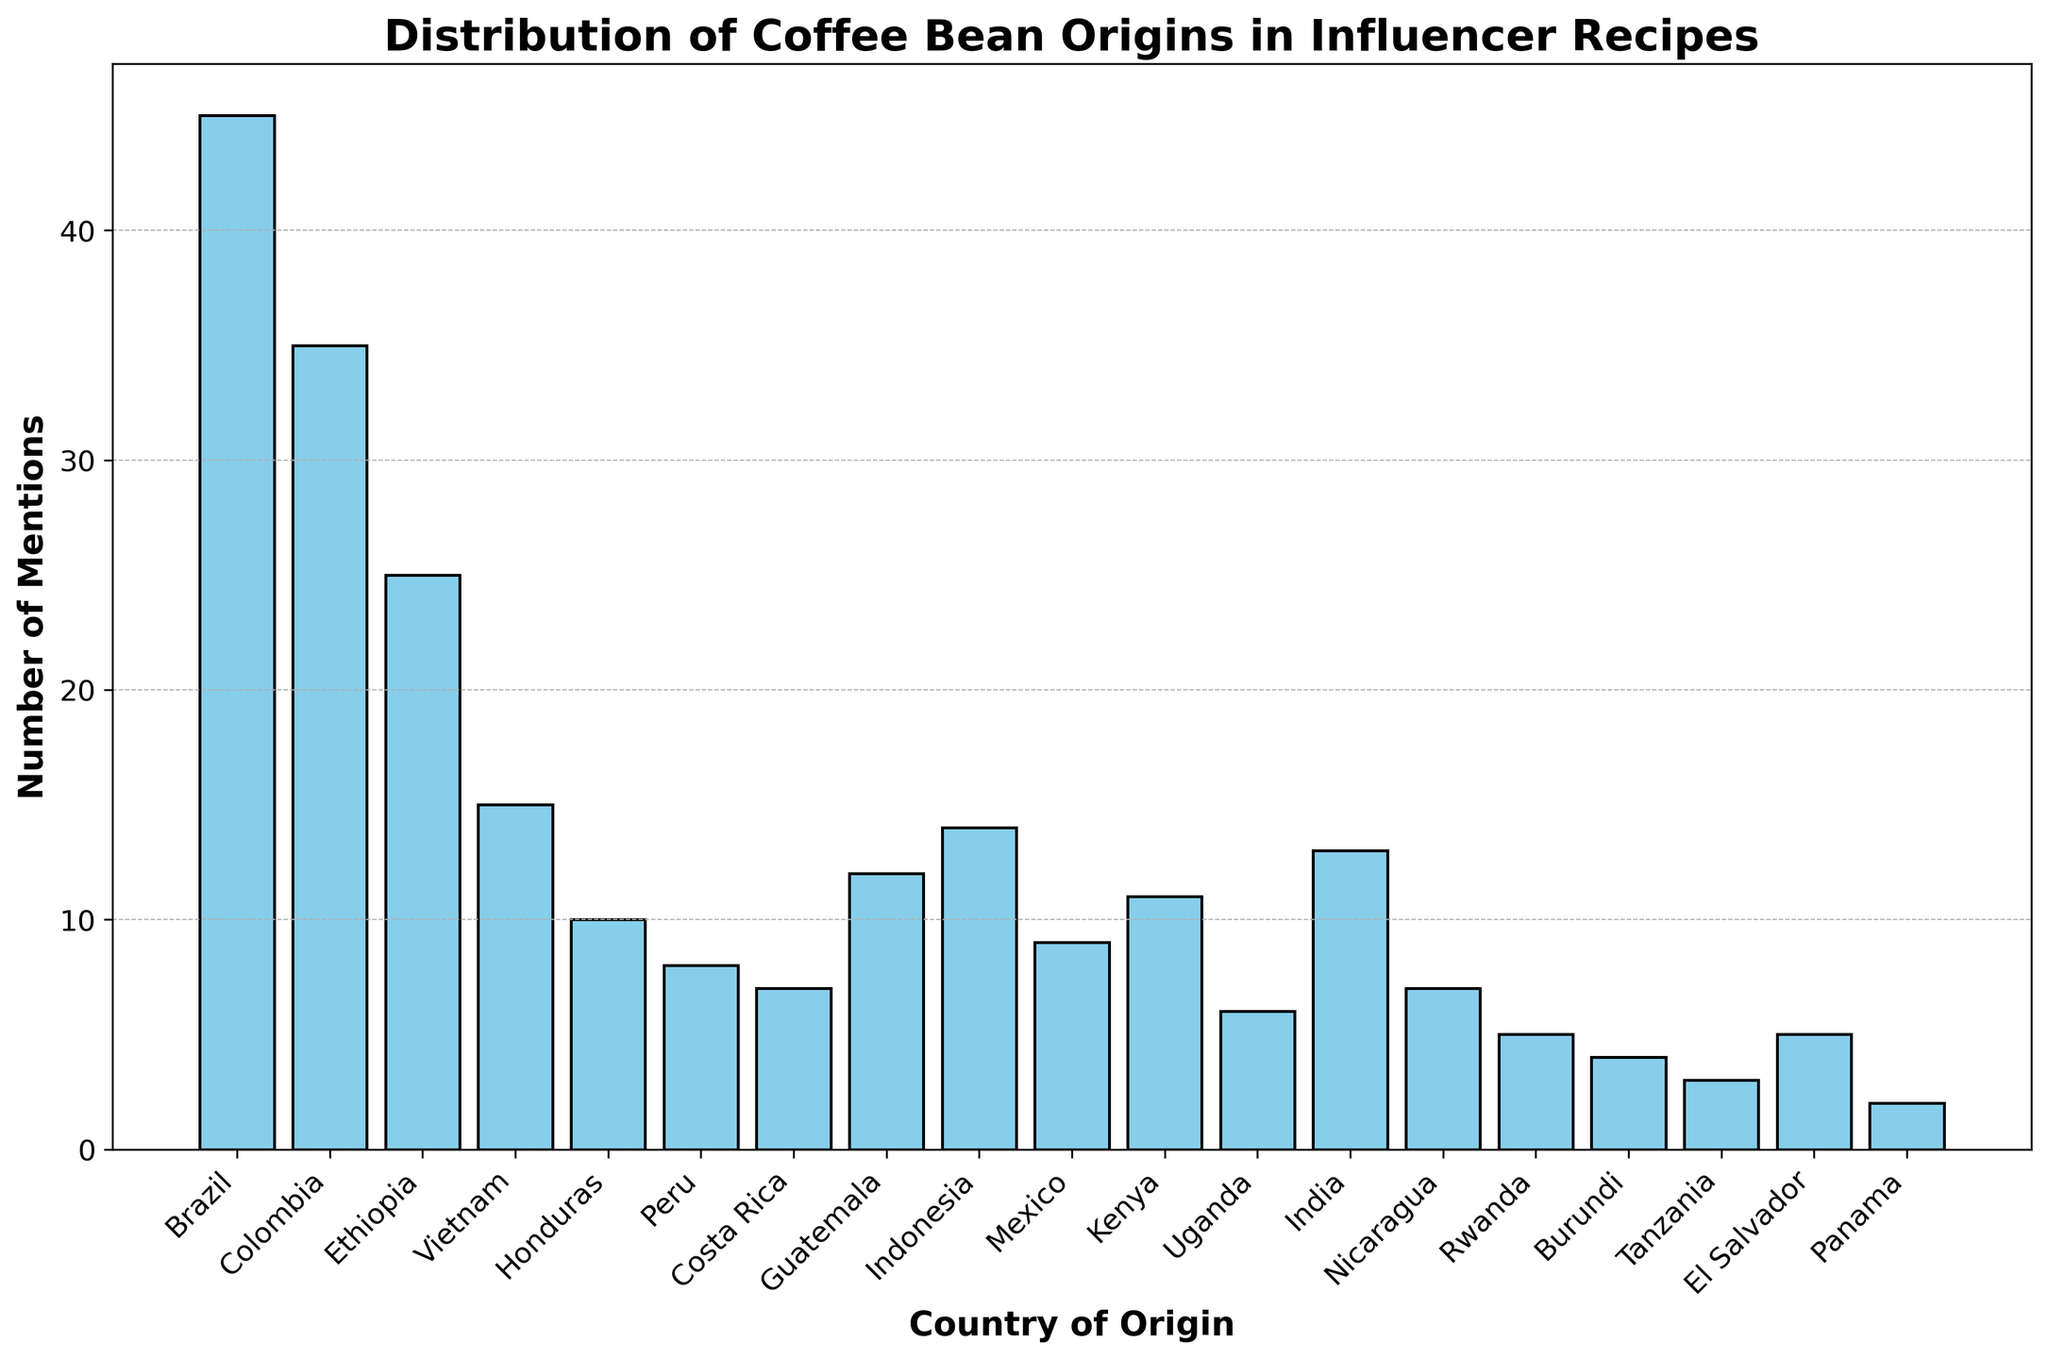Which country has the highest number of mentions? Look at the heights of the bars and identify which bar is the tallest. The tallest bar represents Brazil.
Answer: Brazil Which country is mentioned more often: Guatemala or Costa Rica? Compare the heights of the bars for Guatemala and Costa Rica. Guatemala has 12 mentions, while Costa Rica has 7.
Answer: Guatemala What is the combined total of mentions for Kenya and Uganda? Find the bars for Kenya and Uganda, then add their values. Kenya has 11 mentions and Uganda has 6, so the total is 11 + 6 = 17.
Answer: 17 How many more mentions does Colombia have compared to Vietnam? Compare the bars for Colombia and Vietnam, then subtract the value of Vietnam from Colombia. Colombia has 35 mentions, and Vietnam has 15, so 35 - 15 = 20.
Answer: 20 Are there more countries with mentions less than 10 or equal to or greater than 10? Count the number of countries with mentions less than 10 and those with mentions equal to or greater than 10. Less than 10: Peru, Costa Rica, Mexico, Uganda, Nicaragua, Rwanda, Burundi, Tanzania, El Salvador, Panama (10). Equal to or greater than 10: Brazil, Colombia, Ethiopia, Vietnam, Honduras, Guatemala, Indonesia, Kenya, India (9).
Answer: Less than 10 Which country is second in terms of mentions? Identify the bar with the second-highest height. The second tallest bar represents Colombia with 35 mentions.
Answer: Colombia What is the difference in the number of mentions between Ethiopia and Indonesia? Find the bars for Ethiopia and Indonesia, then subtract the value of Indonesia from Ethiopia. Ethiopia has 25 mentions and Indonesia has 14, so 25 - 14 = 11.
Answer: 11 How many countries have mentions equal to or greater than 10 but less than 20? Count the number of bars that fall within the range of 10 to 19 mentions. Honduras (10), Guatemala (12), Indonesia (14), Kenya (11), India (13) are the countries that fall in this range.
Answer: 5 Which countries have the lowest number of mentions and how many mentions are there? Look for the shortest bars in the plot. The countries with the lowest number of mentions are Panama with 2 mentions and Tanzania with 3 mentions.
Answer: Panama and Tanzania What is the average number of mentions for all the countries? Add up the number of mentions for all countries and divide by the total number of countries. (45 + 35 + 25 + 15 + 10 + 8 + 7 + 12 + 14 + 9 + 11 + 6 + 13 + 7 + 5 + 4 + 3 + 5 + 2) = 236. There are 19 countries, so 236 / 19 ≈ 12.42.
Answer: 12.42 